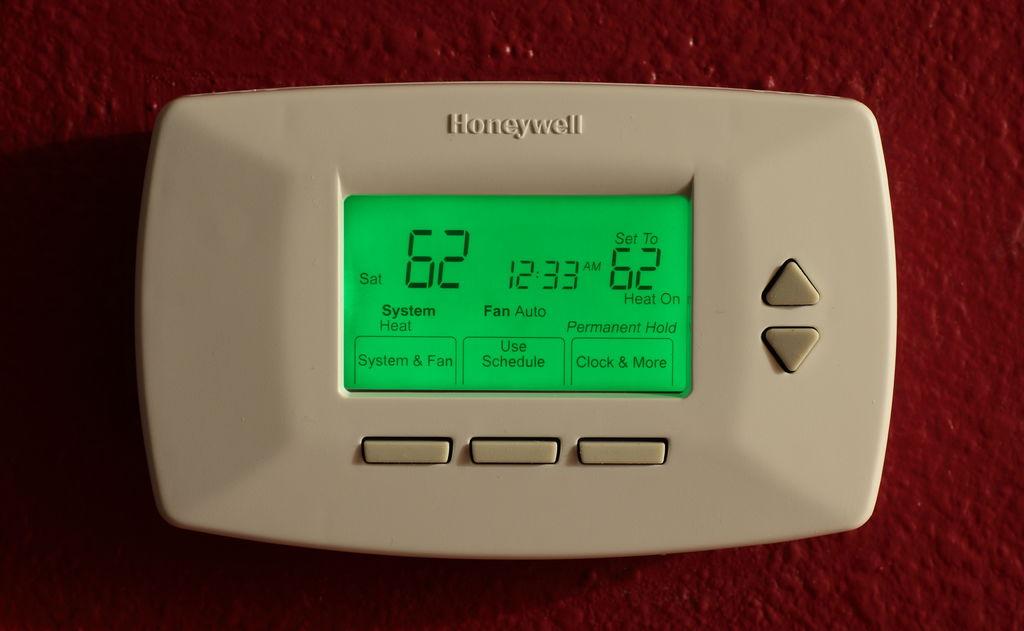What is the temperature?
Your response must be concise. 62. What is the fan set to?
Ensure brevity in your answer.  Auto. 